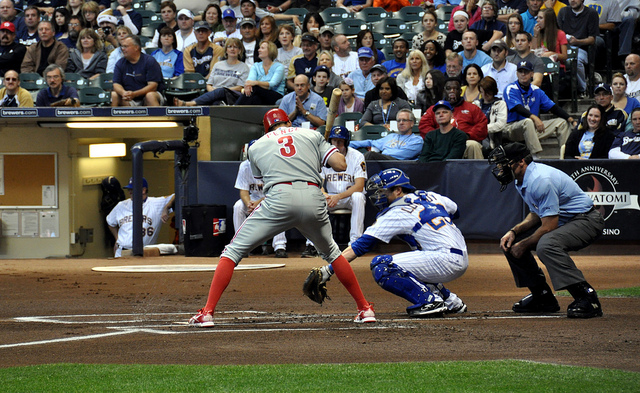Please extract the text content from this image. 3 86 SIHO ANNIVERSARY ATOMI 